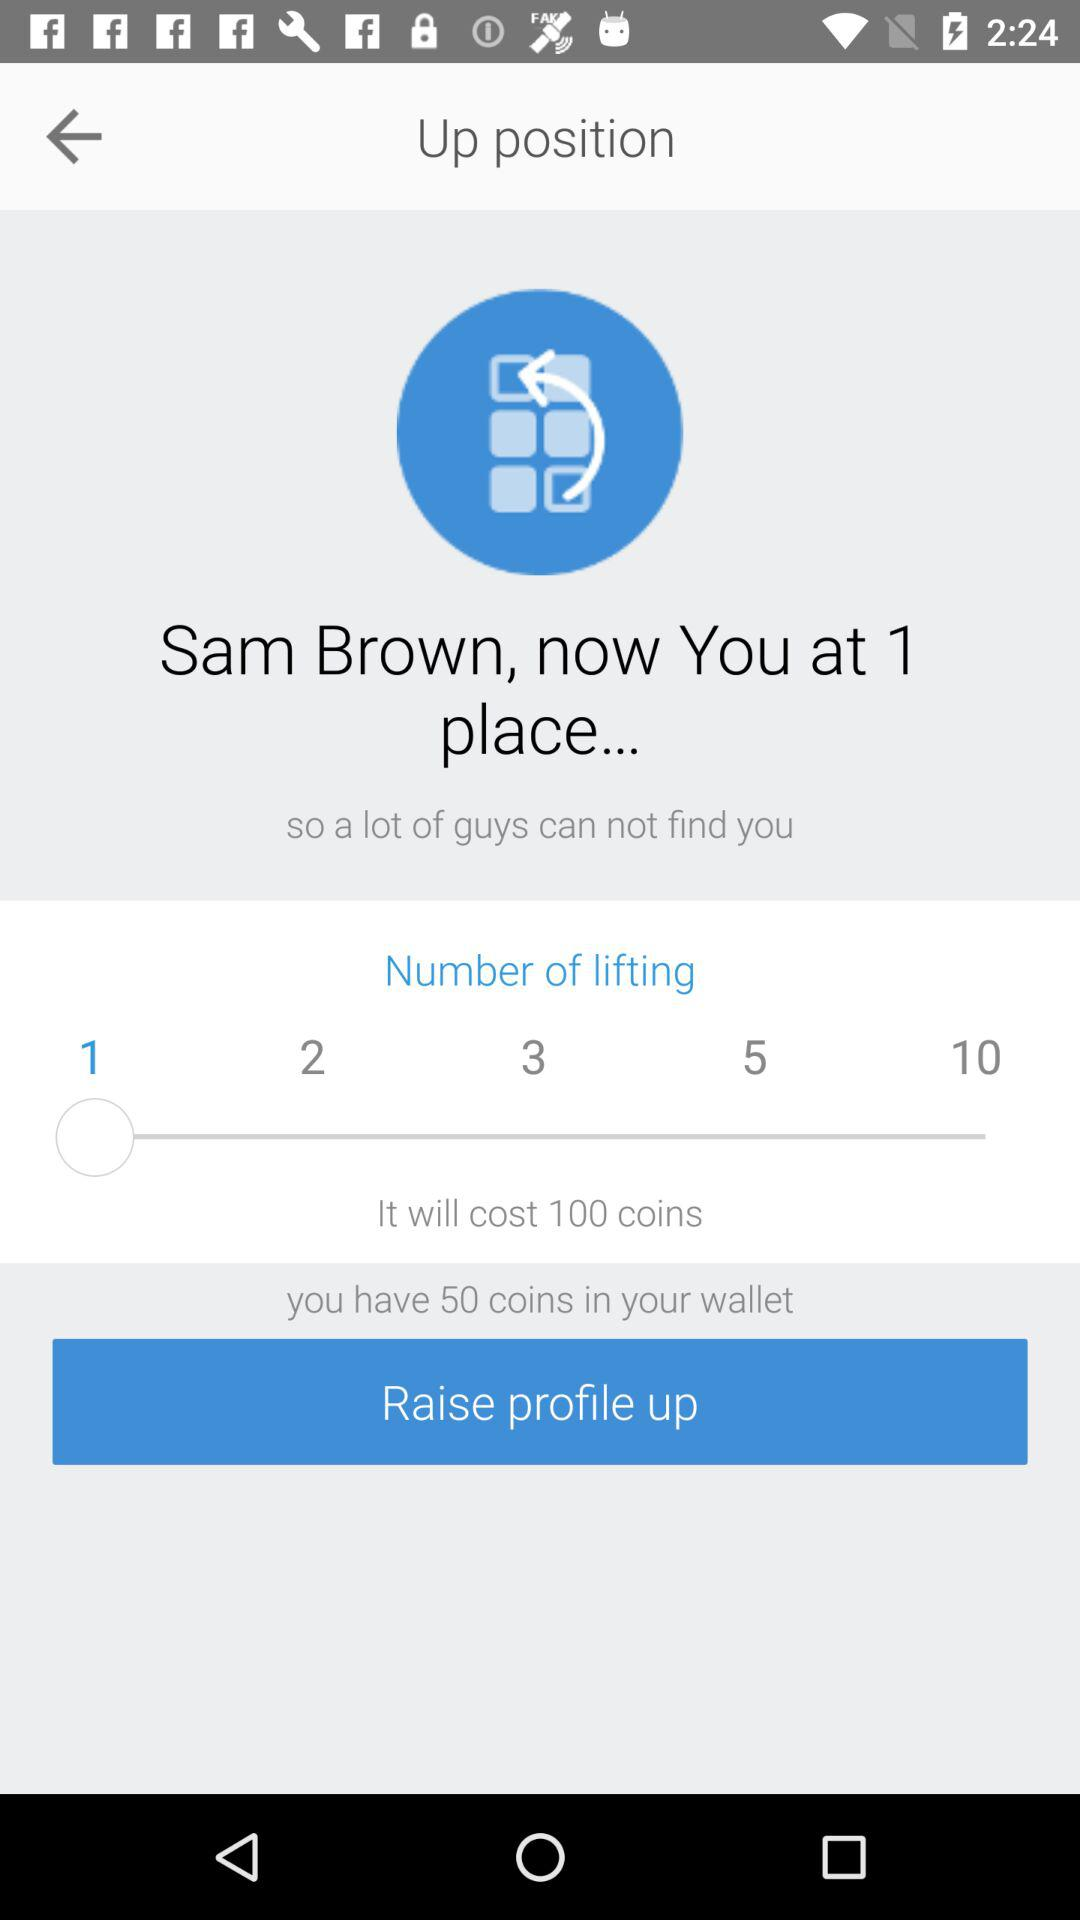How many coins are available in the wallet? There are 50 coins available in the wallet. 